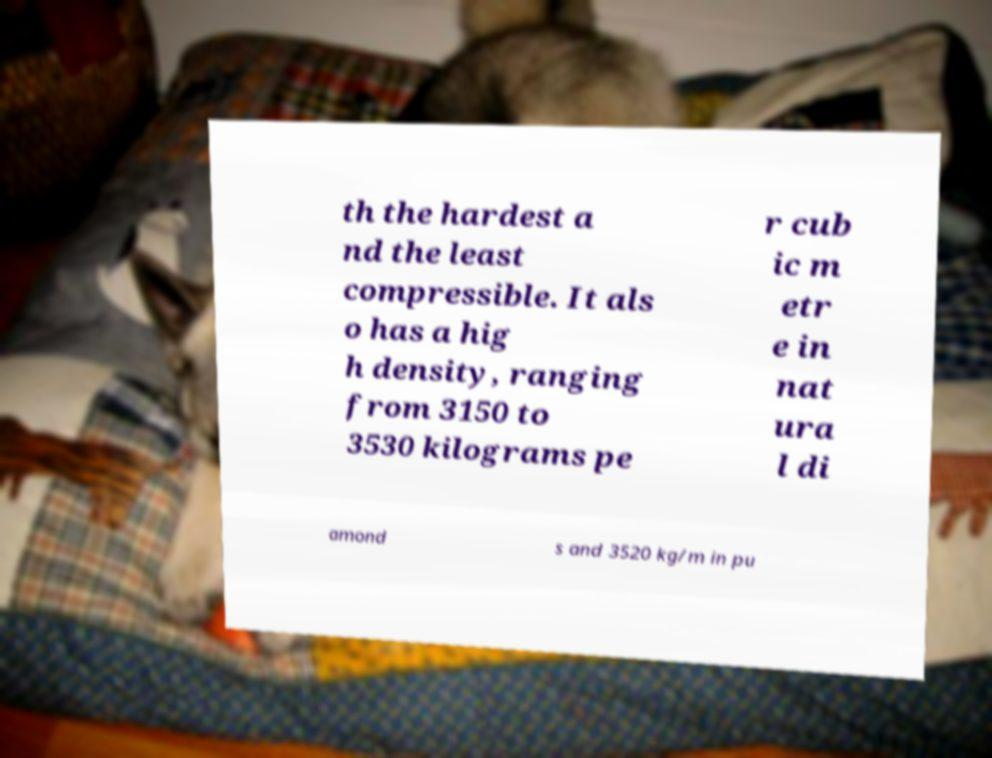Could you extract and type out the text from this image? th the hardest a nd the least compressible. It als o has a hig h density, ranging from 3150 to 3530 kilograms pe r cub ic m etr e in nat ura l di amond s and 3520 kg/m in pu 